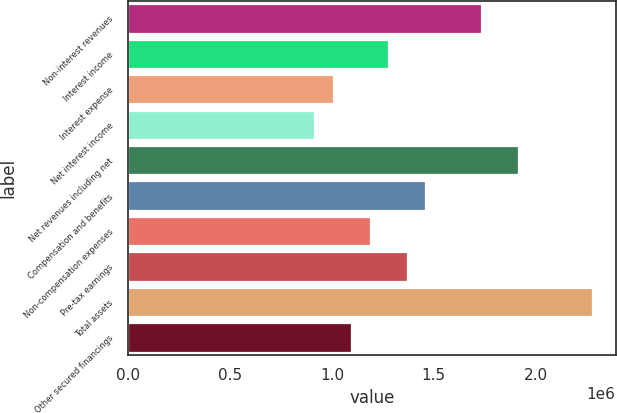Convert chart. <chart><loc_0><loc_0><loc_500><loc_500><bar_chart><fcel>Non-interest revenues<fcel>Interest income<fcel>Interest expense<fcel>Net interest income<fcel>Net revenues including net<fcel>Compensation and benefits<fcel>Non-compensation expenses<fcel>Pre-tax earnings<fcel>Total assets<fcel>Other secured financings<nl><fcel>1.73186e+06<fcel>1.27611e+06<fcel>1.00266e+06<fcel>911507<fcel>1.91416e+06<fcel>1.45841e+06<fcel>1.18496e+06<fcel>1.36726e+06<fcel>2.27876e+06<fcel>1.09381e+06<nl></chart> 